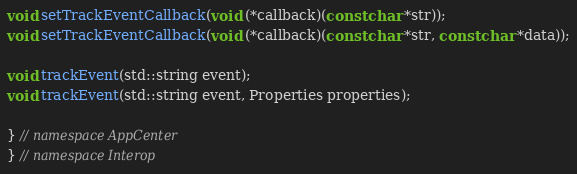<code> <loc_0><loc_0><loc_500><loc_500><_C++_>void setTrackEventCallback(void (*callback)(const char *str));
void setTrackEventCallback(void (*callback)(const char *str, const char *data));

void trackEvent(std::string event);
void trackEvent(std::string event, Properties properties);

} // namespace AppCenter
} // namespace Interop
</code> 